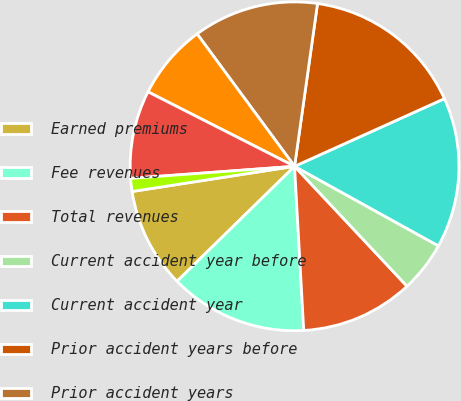Convert chart to OTSL. <chart><loc_0><loc_0><loc_500><loc_500><pie_chart><fcel>Earned premiums<fcel>Fee revenues<fcel>Total revenues<fcel>Current accident year before<fcel>Current accident year<fcel>Prior accident years before<fcel>Prior accident years<fcel>Total loss and loss expenses<fcel>Underwriting expenses<fcel>Total loss and loss expense<nl><fcel>9.88%<fcel>13.56%<fcel>11.1%<fcel>4.97%<fcel>14.79%<fcel>16.02%<fcel>12.33%<fcel>7.42%<fcel>8.65%<fcel>1.28%<nl></chart> 